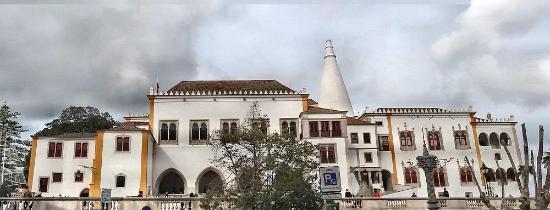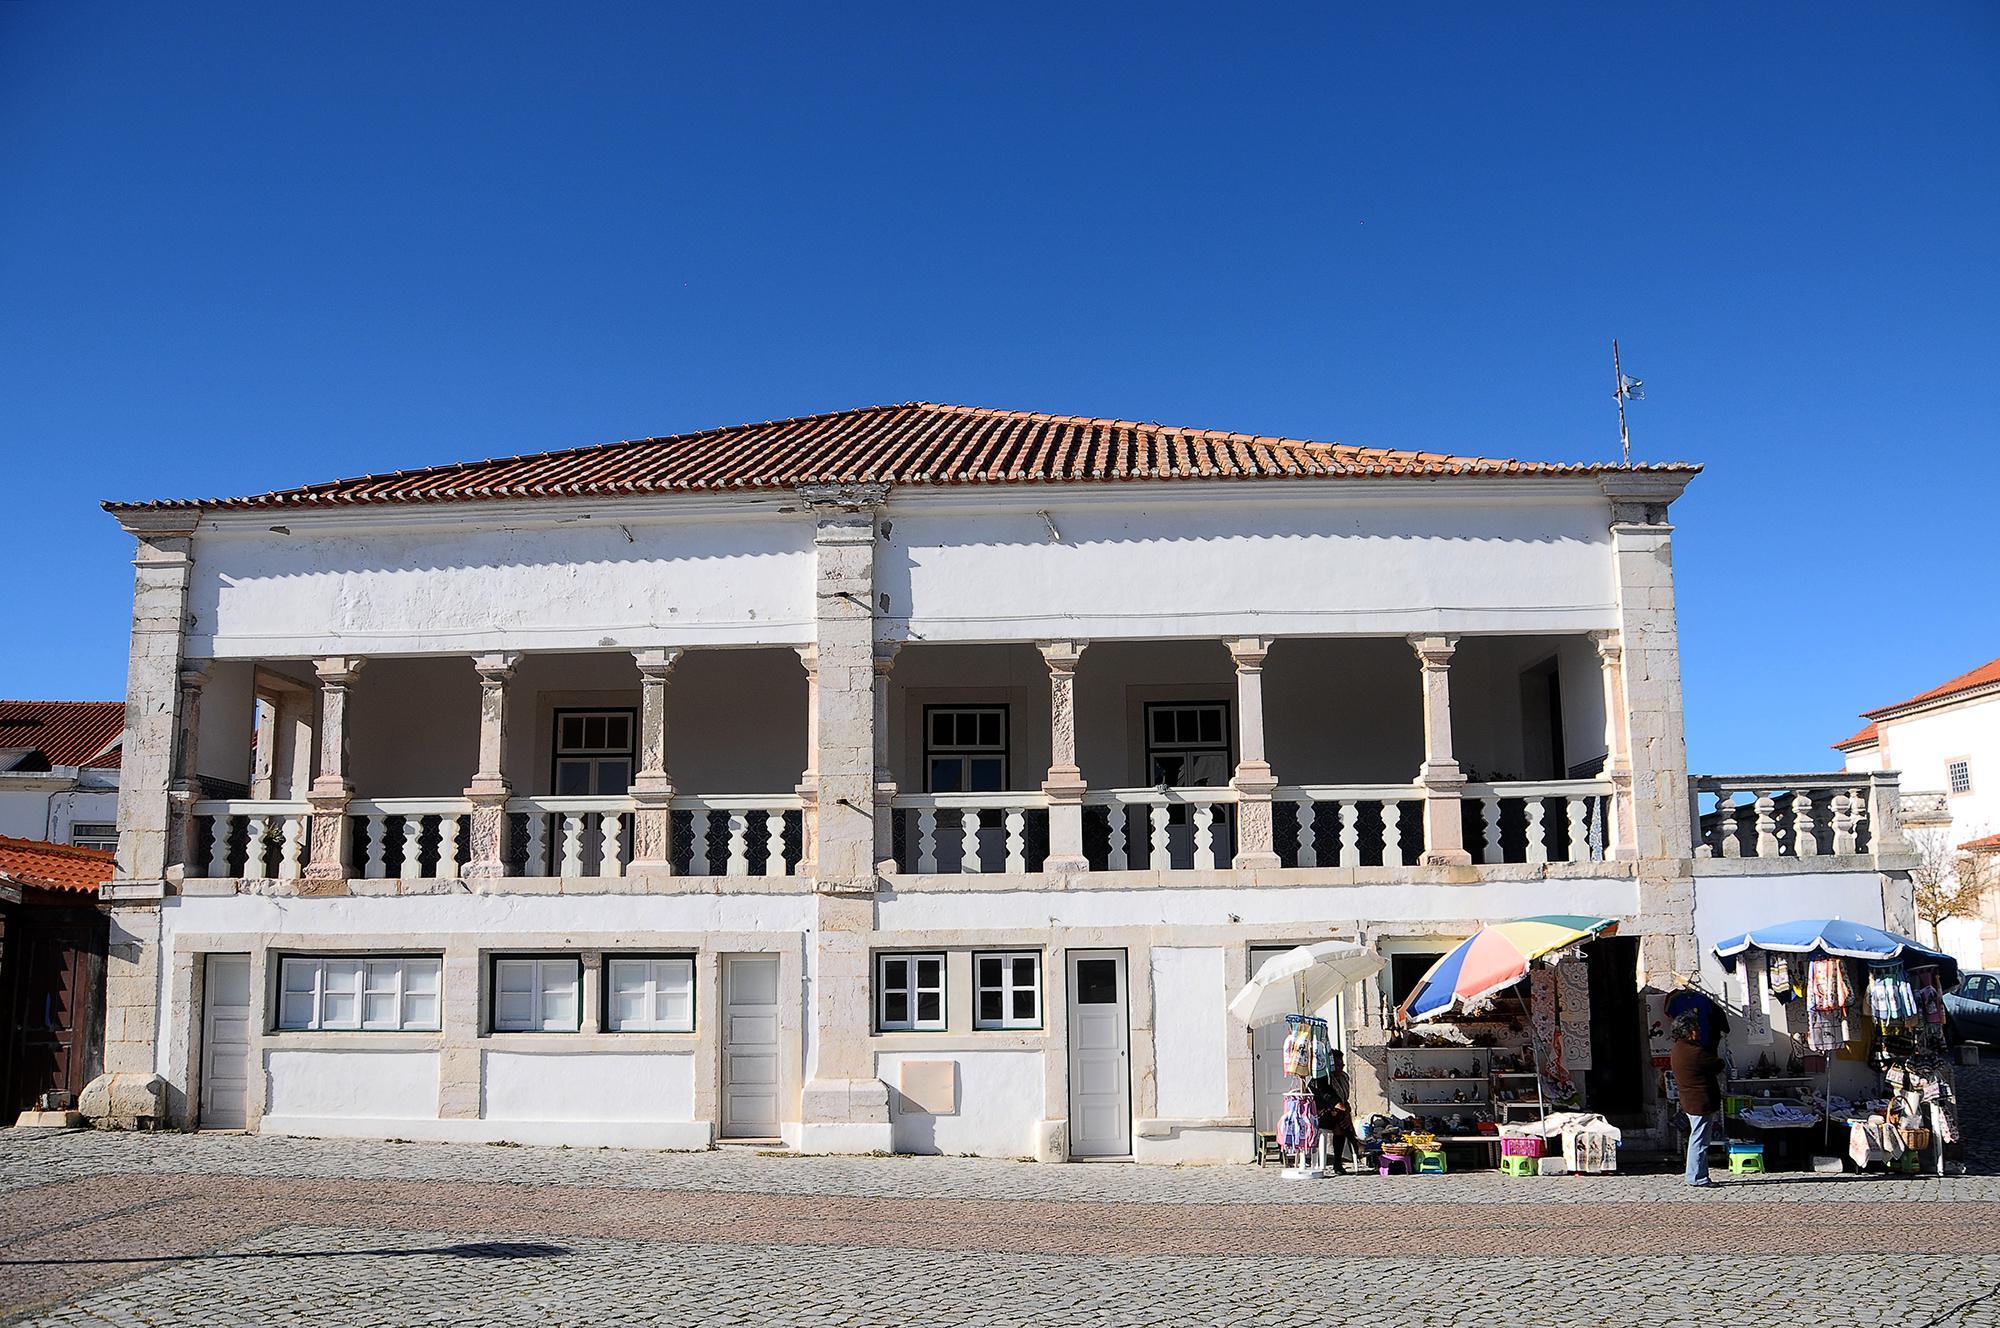The first image is the image on the left, the second image is the image on the right. Assess this claim about the two images: "There are humans in at least one of the images.". Correct or not? Answer yes or no. Yes. The first image is the image on the left, the second image is the image on the right. Given the left and right images, does the statement "There is a round window on top of the main door of a cathedral in the left image." hold true? Answer yes or no. No. 